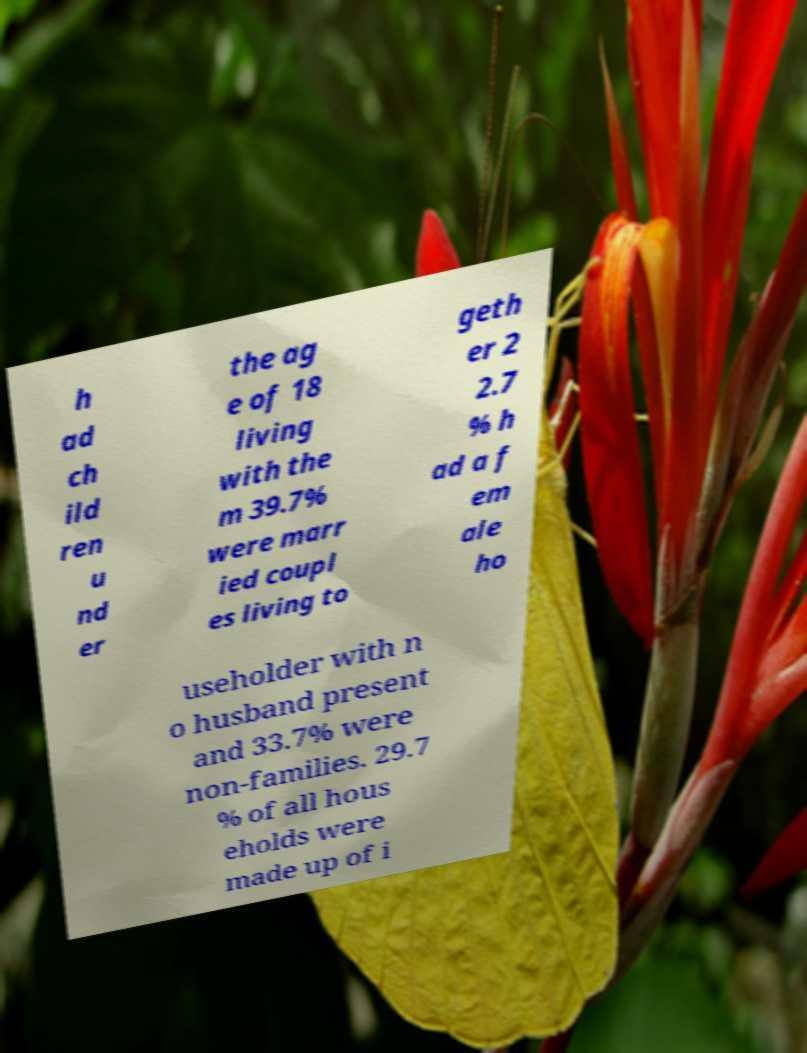For documentation purposes, I need the text within this image transcribed. Could you provide that? h ad ch ild ren u nd er the ag e of 18 living with the m 39.7% were marr ied coupl es living to geth er 2 2.7 % h ad a f em ale ho useholder with n o husband present and 33.7% were non-families. 29.7 % of all hous eholds were made up of i 